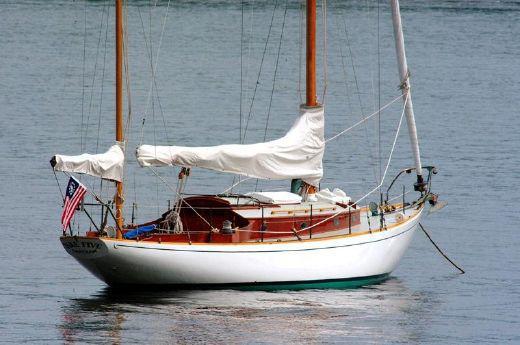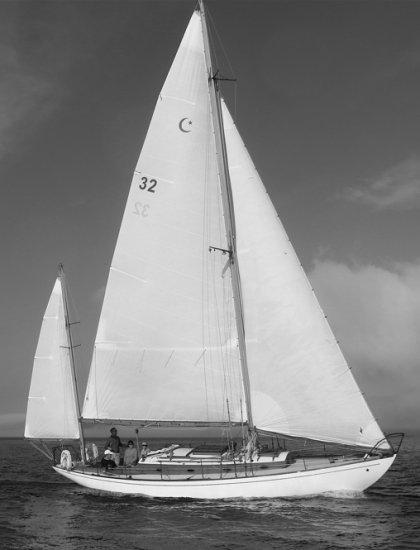The first image is the image on the left, the second image is the image on the right. Considering the images on both sides, is "Neither boat has its sails up." valid? Answer yes or no. No. 